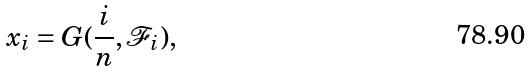<formula> <loc_0><loc_0><loc_500><loc_500>x _ { i } = G ( \frac { i } { n } , \mathcal { F } _ { i } ) ,</formula> 